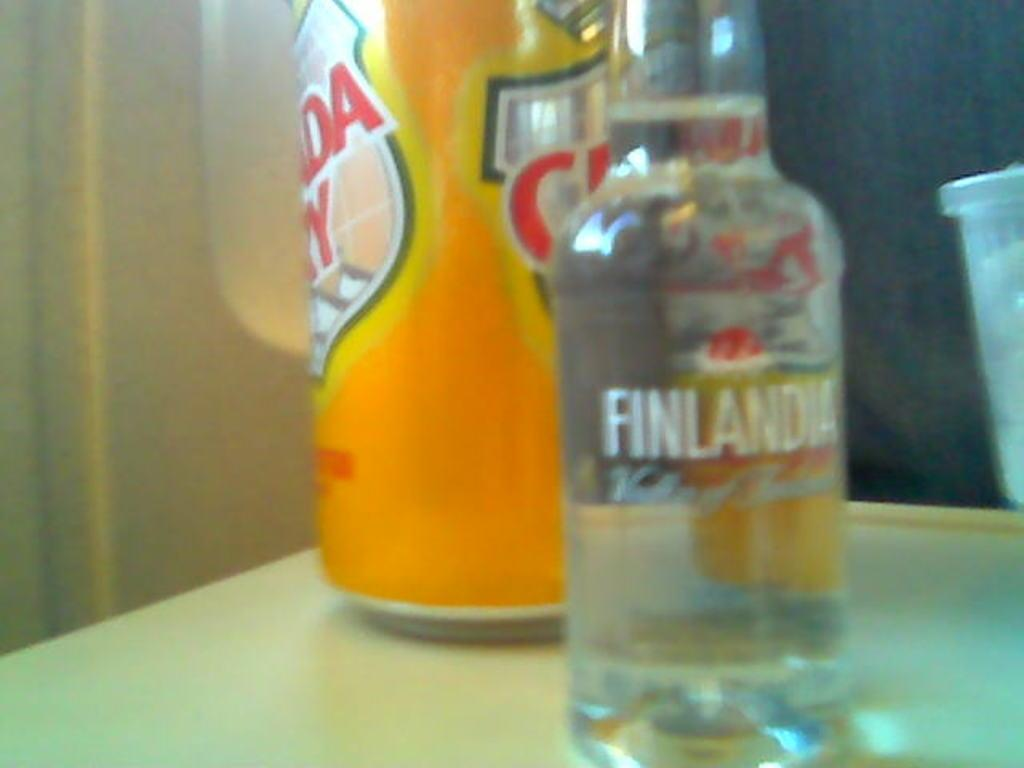<image>
Give a short and clear explanation of the subsequent image. A bottle with Finlandia in white letters and a yellow can with Canada Dry printed on the front 